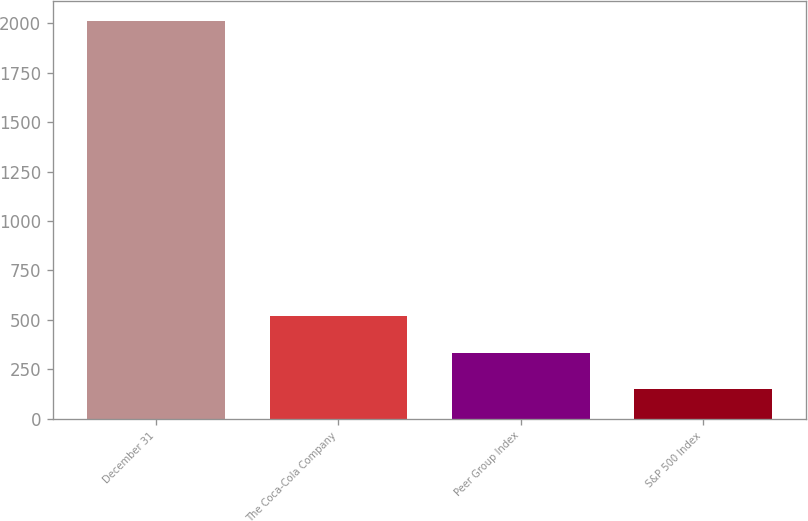<chart> <loc_0><loc_0><loc_500><loc_500><bar_chart><fcel>December 31<fcel>The Coca-Cola Company<fcel>Peer Group Index<fcel>S&P 500 Index<nl><fcel>2011<fcel>521.4<fcel>335.2<fcel>149<nl></chart> 